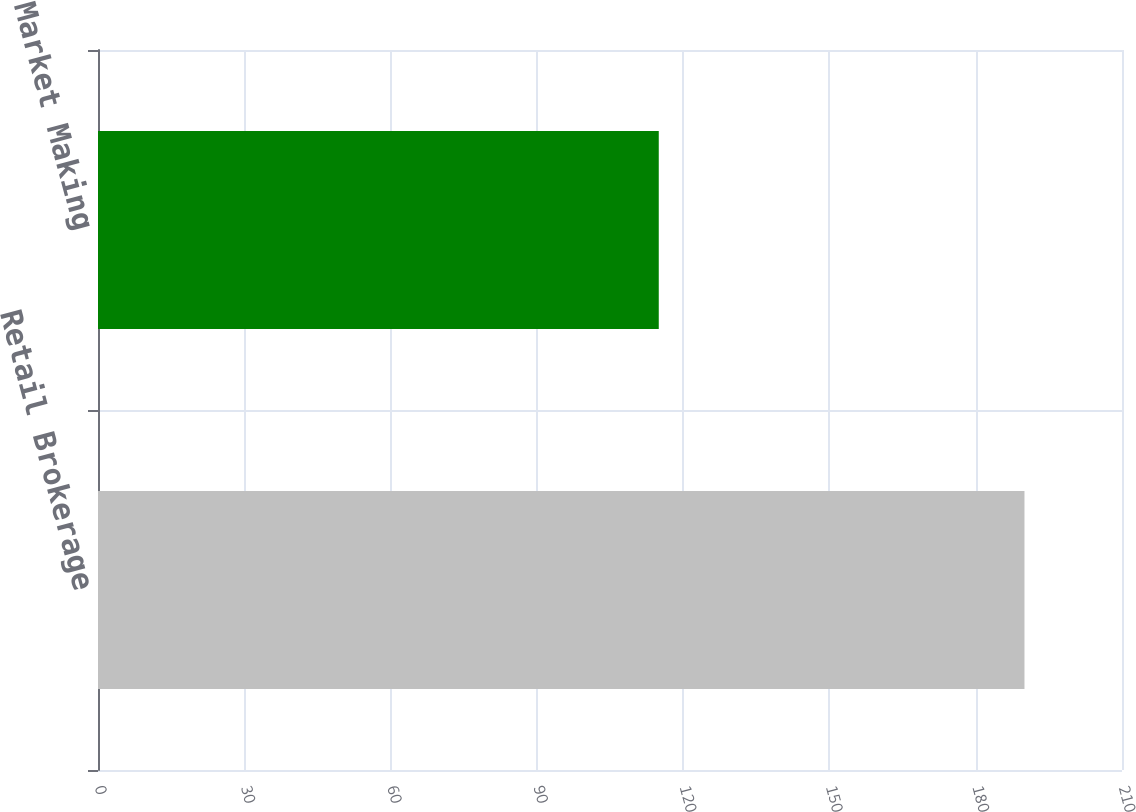Convert chart. <chart><loc_0><loc_0><loc_500><loc_500><bar_chart><fcel>Retail Brokerage<fcel>Market Making<nl><fcel>190<fcel>115<nl></chart> 